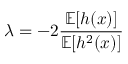Convert formula to latex. <formula><loc_0><loc_0><loc_500><loc_500>\lambda = - 2 \frac { \mathbb { E } [ h ( x ) ] } { \mathbb { E } [ h ^ { 2 } ( x ) ] }</formula> 